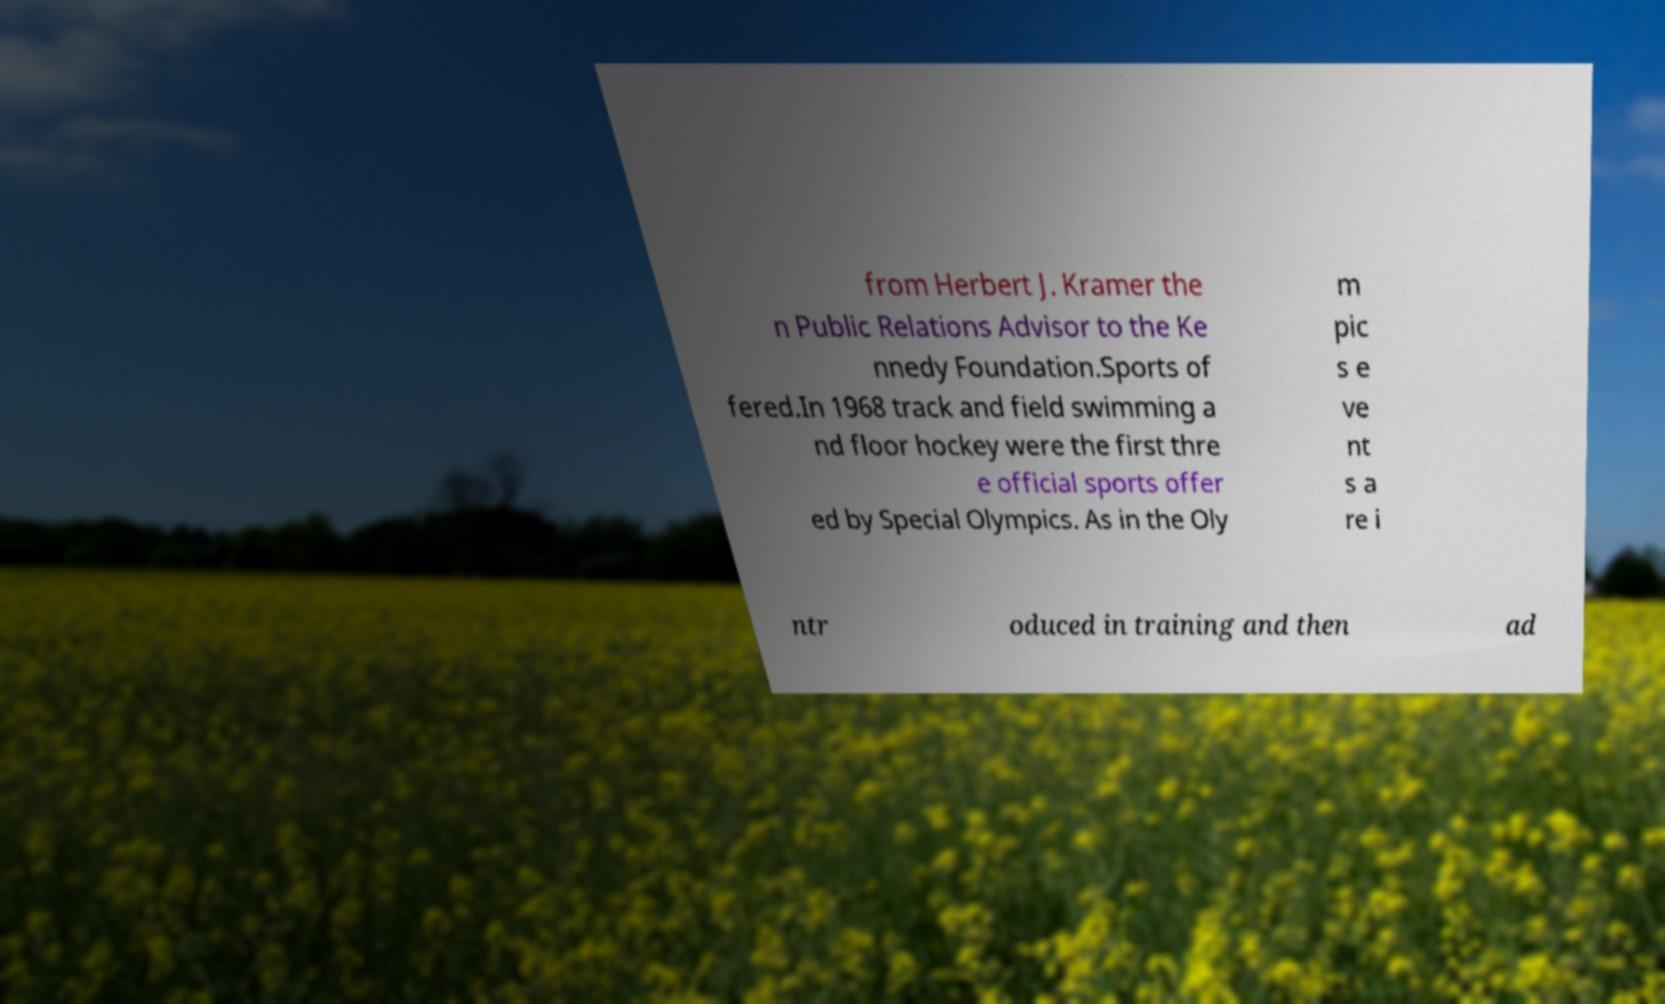I need the written content from this picture converted into text. Can you do that? from Herbert J. Kramer the n Public Relations Advisor to the Ke nnedy Foundation.Sports of fered.In 1968 track and field swimming a nd floor hockey were the first thre e official sports offer ed by Special Olympics. As in the Oly m pic s e ve nt s a re i ntr oduced in training and then ad 